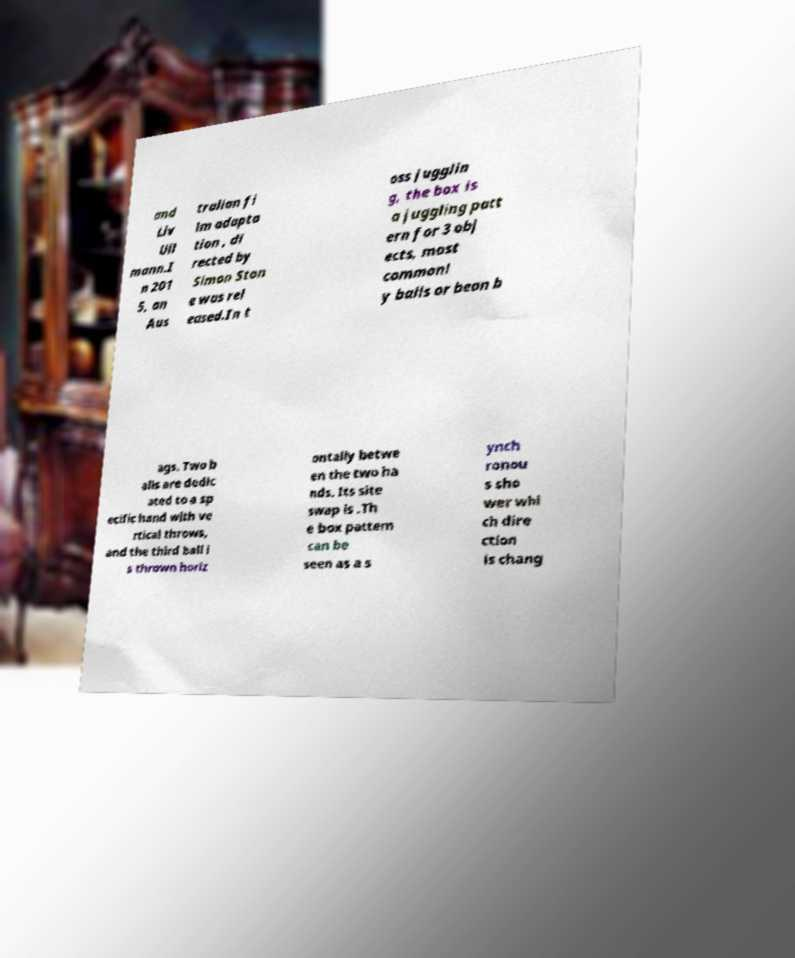Can you accurately transcribe the text from the provided image for me? and Liv Ull mann.I n 201 5, an Aus tralian fi lm adapta tion , di rected by Simon Ston e was rel eased.In t oss jugglin g, the box is a juggling patt ern for 3 obj ects, most commonl y balls or bean b ags. Two b alls are dedic ated to a sp ecific hand with ve rtical throws, and the third ball i s thrown horiz ontally betwe en the two ha nds. Its site swap is .Th e box pattern can be seen as a s ynch ronou s sho wer whi ch dire ction is chang 